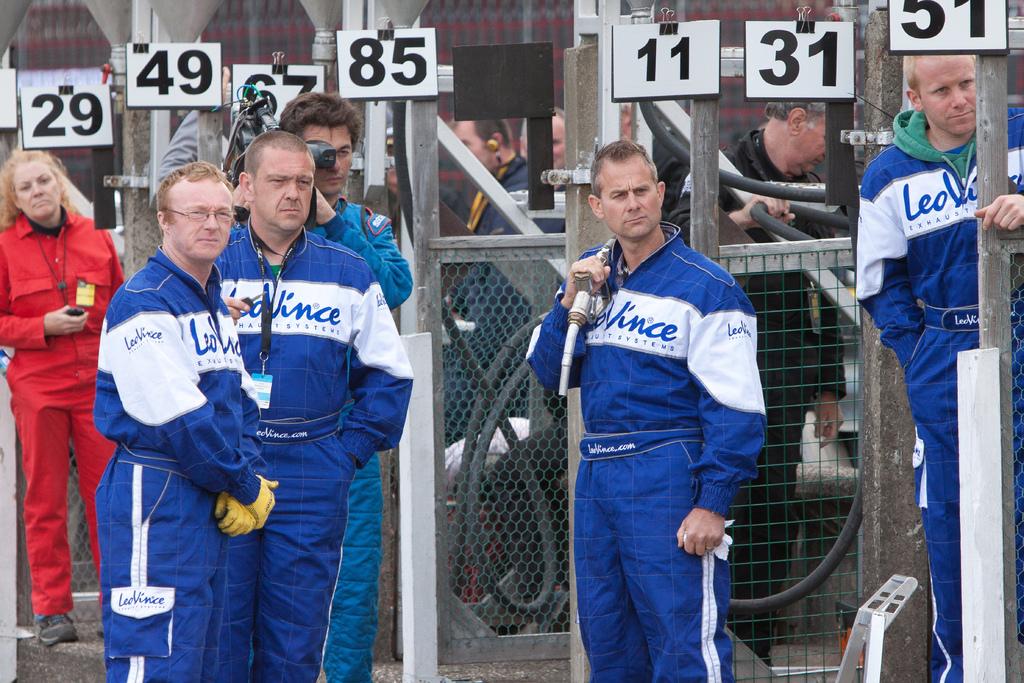What is number to the right of 11?
Make the answer very short. 31. Order the numbers from least to greatest?
Offer a terse response. 11 29 31 49 51 67 85. 